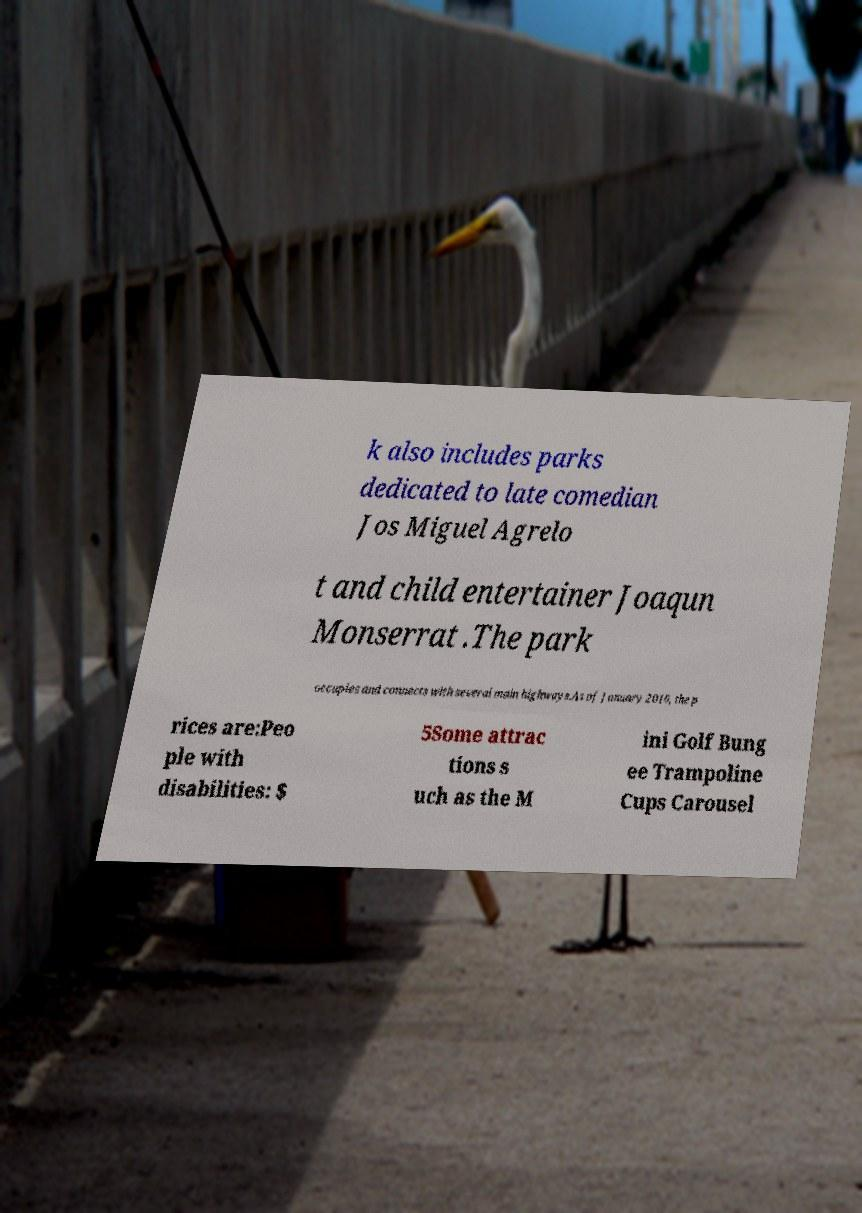There's text embedded in this image that I need extracted. Can you transcribe it verbatim? k also includes parks dedicated to late comedian Jos Miguel Agrelo t and child entertainer Joaqun Monserrat .The park occupies and connects with several main highways.As of January 2016, the p rices are:Peo ple with disabilities: $ 5Some attrac tions s uch as the M ini Golf Bung ee Trampoline Cups Carousel 